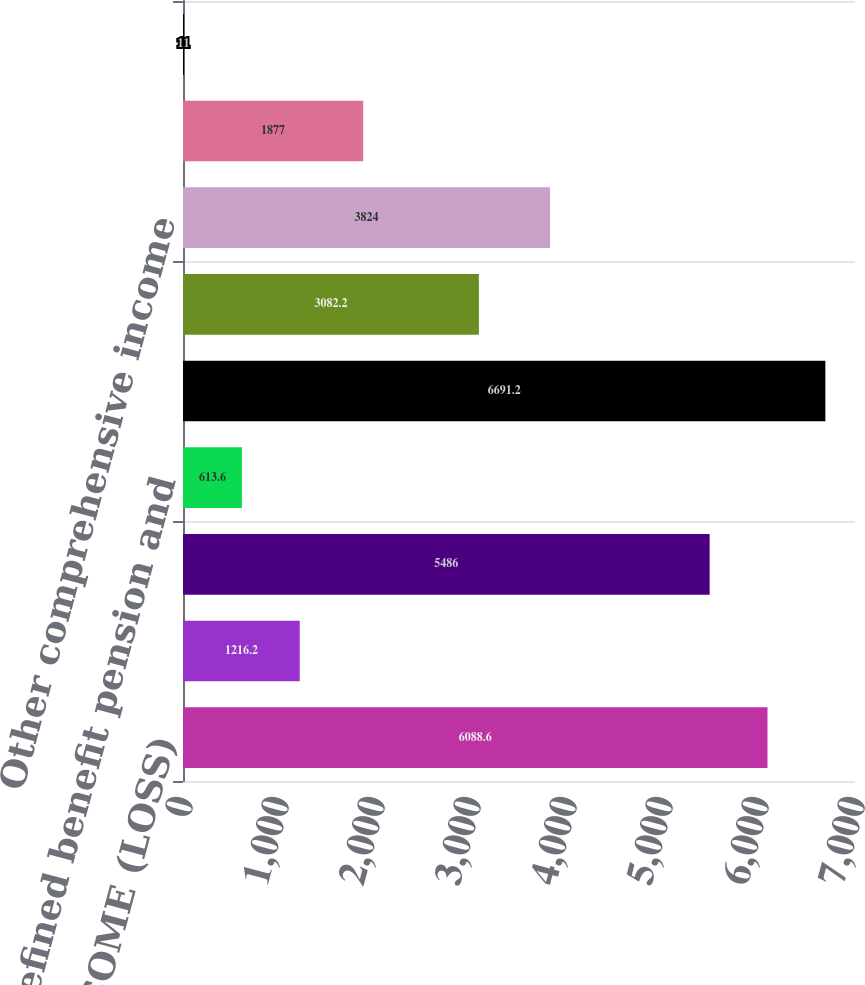Convert chart. <chart><loc_0><loc_0><loc_500><loc_500><bar_chart><fcel>NET INCOME (LOSS)<fcel>Foreign currency translation<fcel>Net unrealized investment<fcel>Defined benefit pension and<fcel>Total<fcel>Less Income tax expense<fcel>Other comprehensive income<fcel>Comprehensive income (loss)<fcel>Less Comprehensive income<nl><fcel>6088.6<fcel>1216.2<fcel>5486<fcel>613.6<fcel>6691.2<fcel>3082.2<fcel>3824<fcel>1877<fcel>11<nl></chart> 